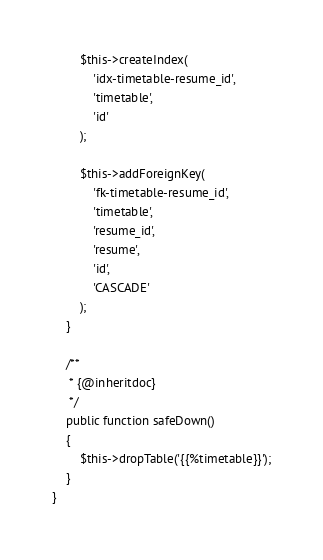<code> <loc_0><loc_0><loc_500><loc_500><_PHP_>
        $this->createIndex(
            'idx-timetable-resume_id',
            'timetable',
            'id'
        );

        $this->addForeignKey(
            'fk-timetable-resume_id',
            'timetable',
            'resume_id',
            'resume',
            'id',
            'CASCADE'
        );
    }

    /**
     * {@inheritdoc}
     */
    public function safeDown()
    {
        $this->dropTable('{{%timetable}}');
    }
}
</code> 